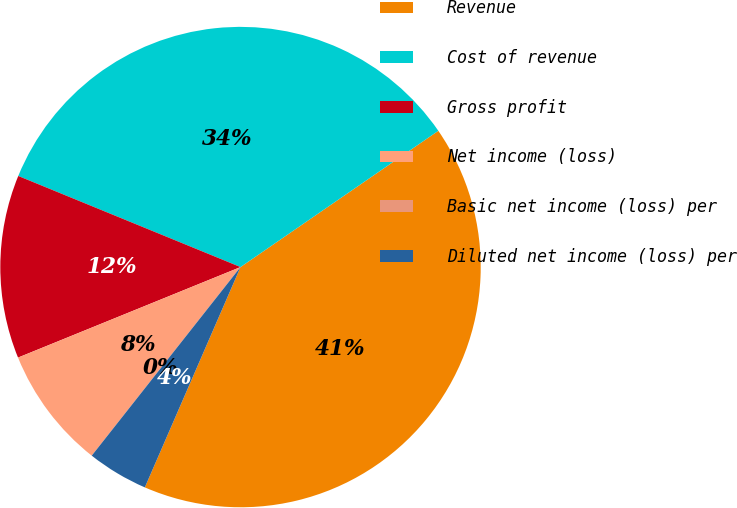Convert chart. <chart><loc_0><loc_0><loc_500><loc_500><pie_chart><fcel>Revenue<fcel>Cost of revenue<fcel>Gross profit<fcel>Net income (loss)<fcel>Basic net income (loss) per<fcel>Diluted net income (loss) per<nl><fcel>41.12%<fcel>34.21%<fcel>12.34%<fcel>8.22%<fcel>0.0%<fcel>4.11%<nl></chart> 